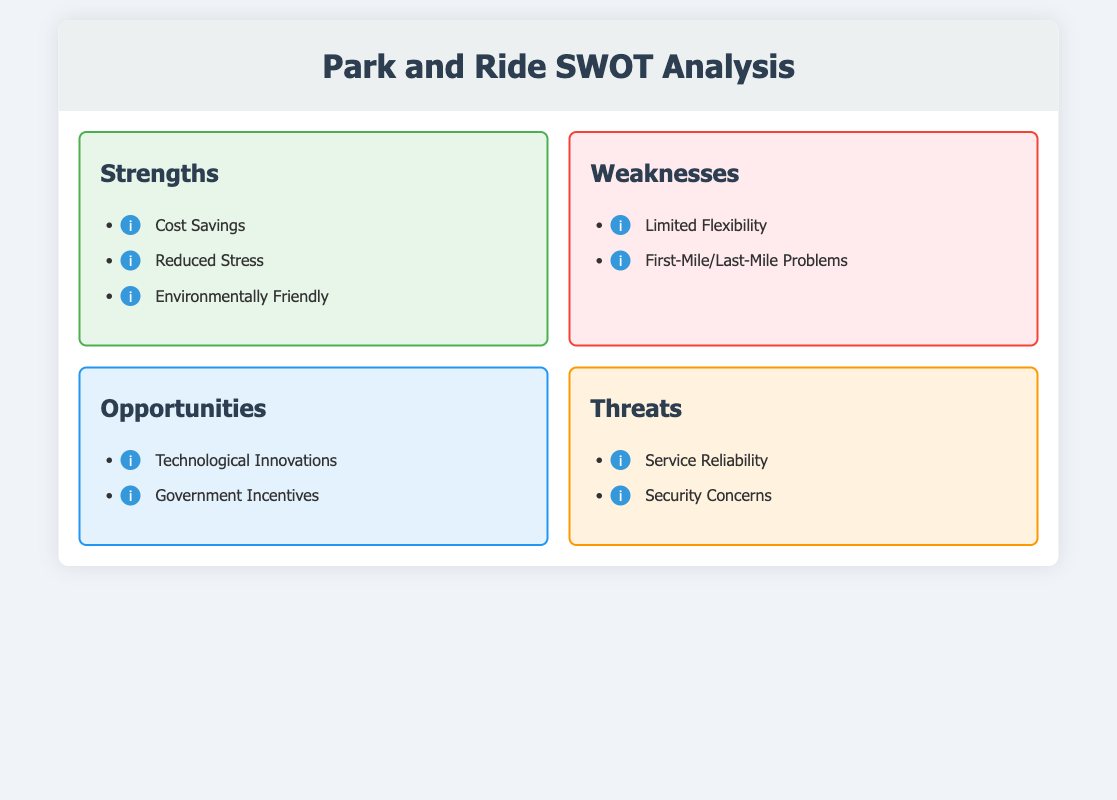What are the strengths of Park and Ride services? The strengths are listed in the "Strengths" section of the document.
Answer: Cost Savings, Reduced Stress, Environmentally Friendly What is one weakness of Park and Ride services? The weaknesses are listed in the "Weaknesses" section of the document.
Answer: Limited Flexibility What are two opportunities mentioned in the analysis? The opportunities are found in the "Opportunities" section of the document.
Answer: Technological Innovations, Government Incentives What threat is associated with service reliability? The threat is mentioned in the "Threats" section regarding service reliability.
Answer: Service Reliability How many strengths are listed in the document? The strengths are outlined in a list; counting them gives the total.
Answer: 3 